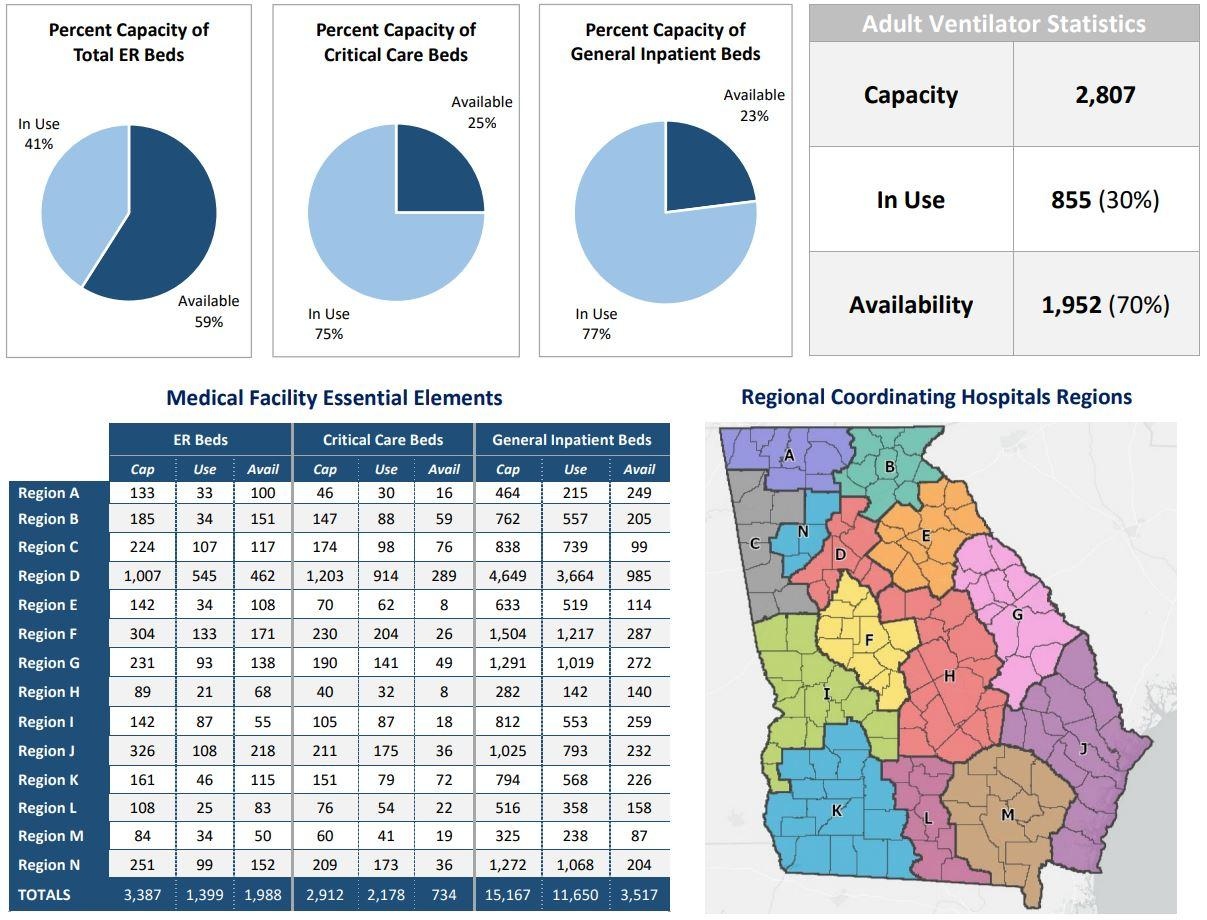Specify some key components in this picture. Region B has 52 more total number of ER beds compared to Region A. Region D has 874 more total number of ER beds compared to Region A. Region D has a total of 4,185 more General Inpatient beds than Region A. There are 74 additional total emergency beds than the total number of critical care beds in region F. As of 2021, the total number of ER beds in all regions is 3,387. 